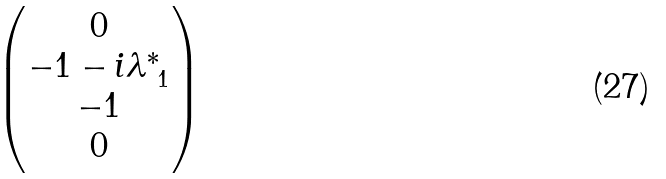<formula> <loc_0><loc_0><loc_500><loc_500>\begin{pmatrix} 0 \\ - 1 - i \lambda _ { \ 1 } ^ { * } \\ - 1 \\ 0 \end{pmatrix}</formula> 